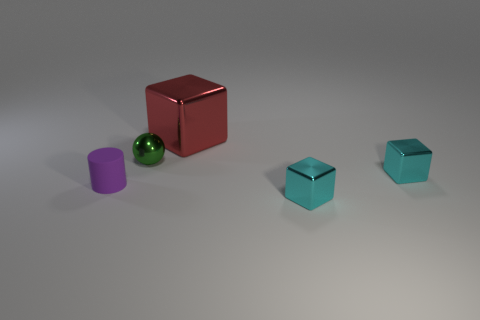Does the arrangement of the objects tell us anything about their relationship or is there a pattern? The arrangement appears deliberate, with the objects evenly spaced and oriented similarly. There is no clear pattern, but the placement may suggest a sense of balance or a study in geometry through the use of different shapes and contrasting colors. 